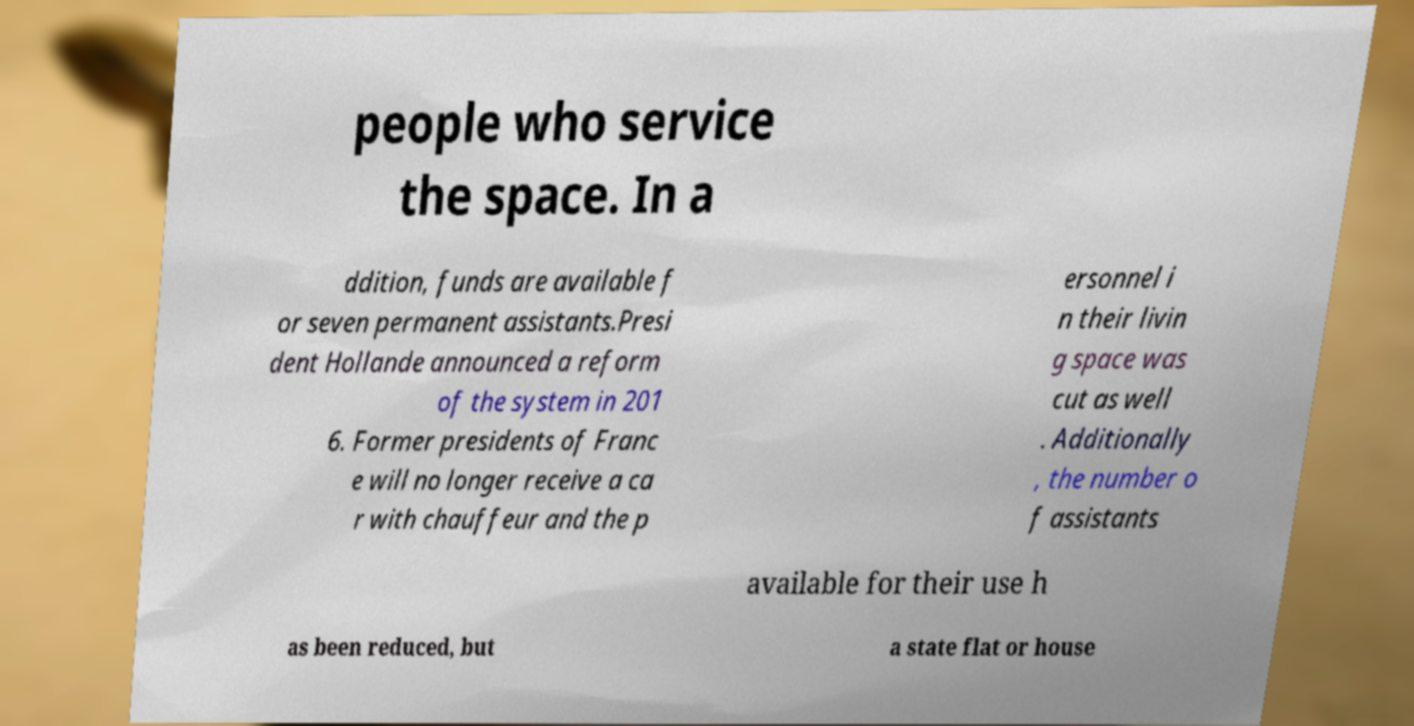There's text embedded in this image that I need extracted. Can you transcribe it verbatim? people who service the space. In a ddition, funds are available f or seven permanent assistants.Presi dent Hollande announced a reform of the system in 201 6. Former presidents of Franc e will no longer receive a ca r with chauffeur and the p ersonnel i n their livin g space was cut as well . Additionally , the number o f assistants available for their use h as been reduced, but a state flat or house 